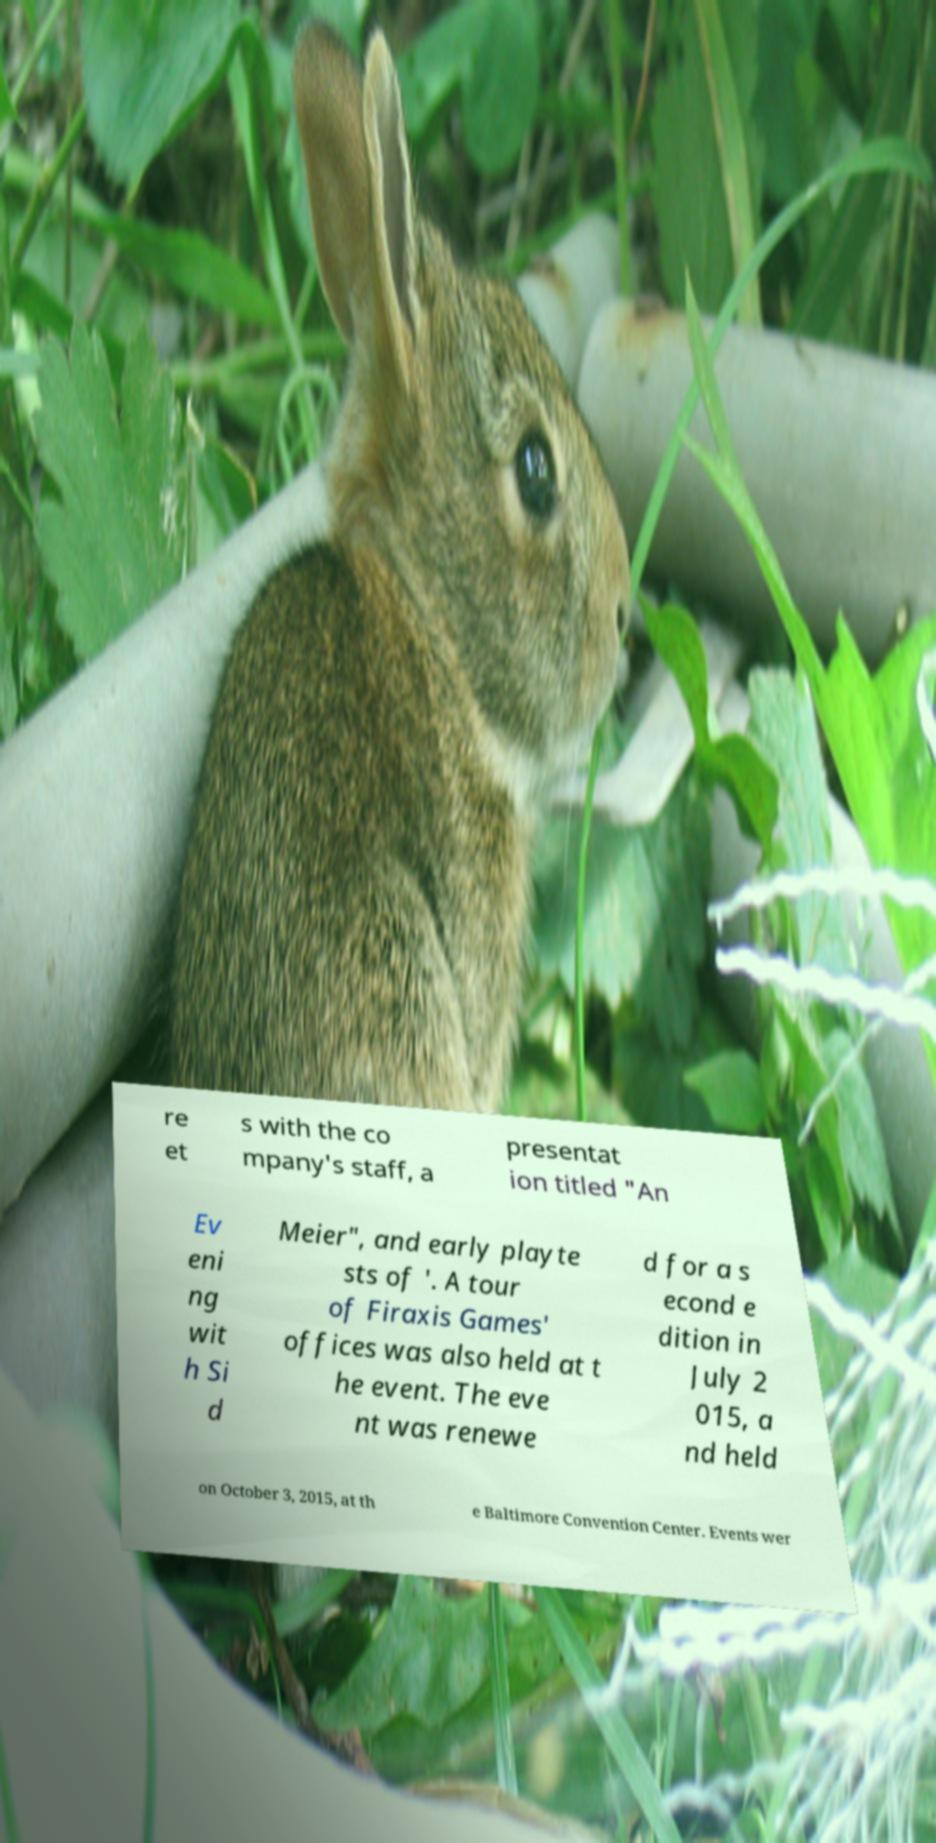Could you assist in decoding the text presented in this image and type it out clearly? re et s with the co mpany's staff, a presentat ion titled "An Ev eni ng wit h Si d Meier", and early playte sts of '. A tour of Firaxis Games' offices was also held at t he event. The eve nt was renewe d for a s econd e dition in July 2 015, a nd held on October 3, 2015, at th e Baltimore Convention Center. Events wer 